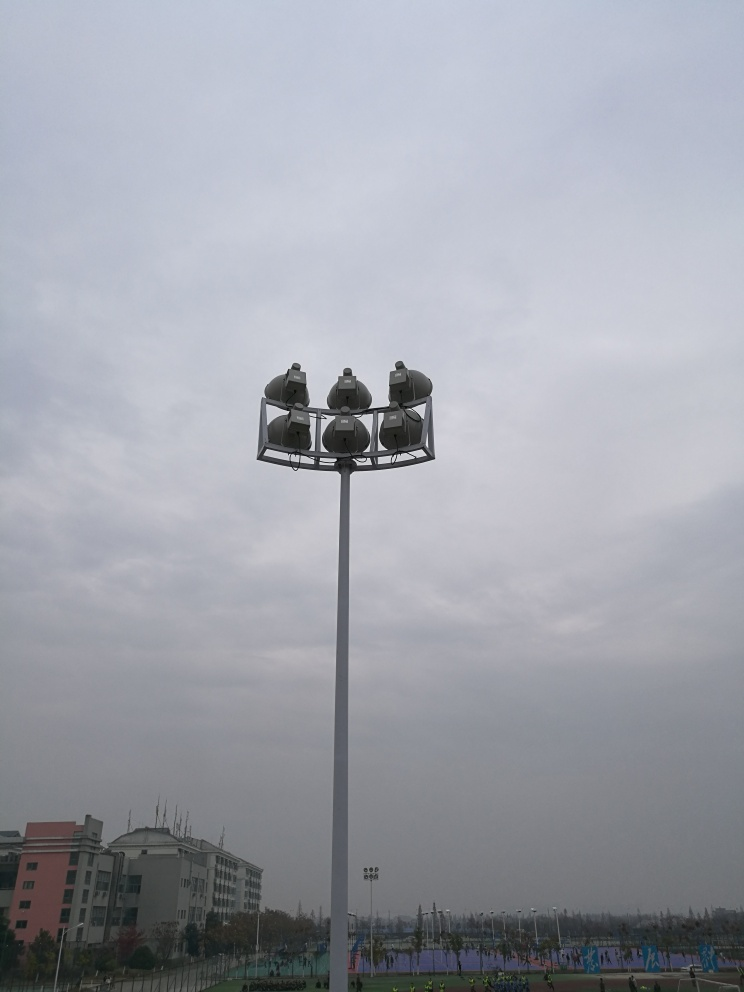Is the image clear? The image is moderately clear, capturing a towering light pole with multiple fixtures against a cloudy sky, overlooking what appears to be a sports area with visible activity in the background. The overcast conditions contribute to the image's somewhat muted colors. 